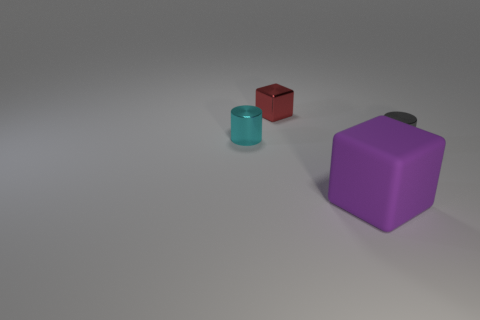How many other big purple objects are the same material as the purple thing?
Make the answer very short. 0. Are there more tiny objects than small cubes?
Your answer should be very brief. Yes. What number of shiny objects are behind the small metal cylinder right of the tiny red shiny cube?
Your answer should be compact. 2. What number of things are tiny metallic cylinders in front of the small cyan metal cylinder or tiny gray cylinders?
Ensure brevity in your answer.  1. Is there another purple rubber thing that has the same shape as the large purple object?
Ensure brevity in your answer.  No. What shape is the object in front of the shiny cylinder that is to the right of the cyan cylinder?
Offer a very short reply. Cube. How many cylinders are either shiny objects or small cyan shiny things?
Your response must be concise. 2. Is the shape of the object in front of the gray metal thing the same as the metal thing that is on the right side of the large rubber cube?
Make the answer very short. No. The object that is in front of the cyan cylinder and behind the big purple block is what color?
Offer a terse response. Gray. There is a big rubber block; is it the same color as the tiny metal cylinder to the right of the tiny cube?
Your response must be concise. No. 